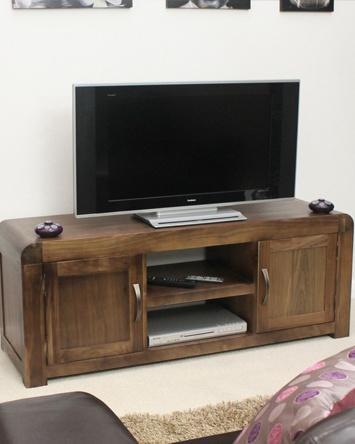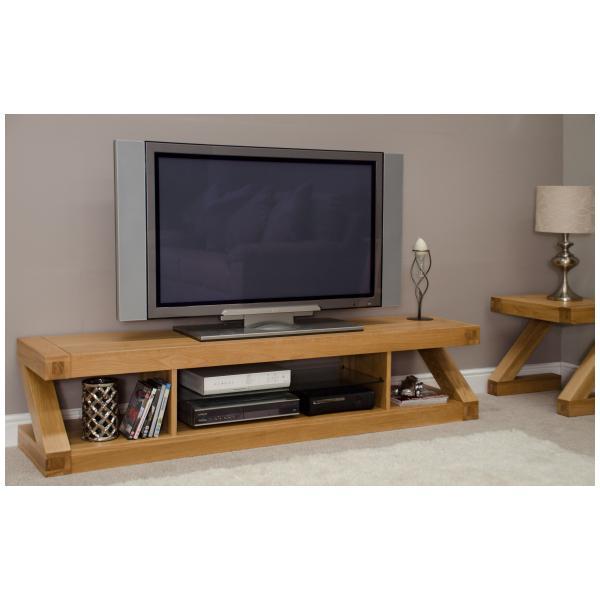The first image is the image on the left, the second image is the image on the right. Analyze the images presented: Is the assertion "One picture is sitting on a TV stand next to the TV." valid? Answer yes or no. No. The first image is the image on the left, the second image is the image on the right. Considering the images on both sides, is "One image shows a flatscreen TV on a low-slung stand with solid doors on each end and two open shelves in the middle." valid? Answer yes or no. Yes. 